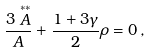Convert formula to latex. <formula><loc_0><loc_0><loc_500><loc_500>\frac { 3 \stackrel { \ast \ast } { A } } { A } + \frac { 1 + 3 \gamma } { 2 } \rho = 0 \, ,</formula> 